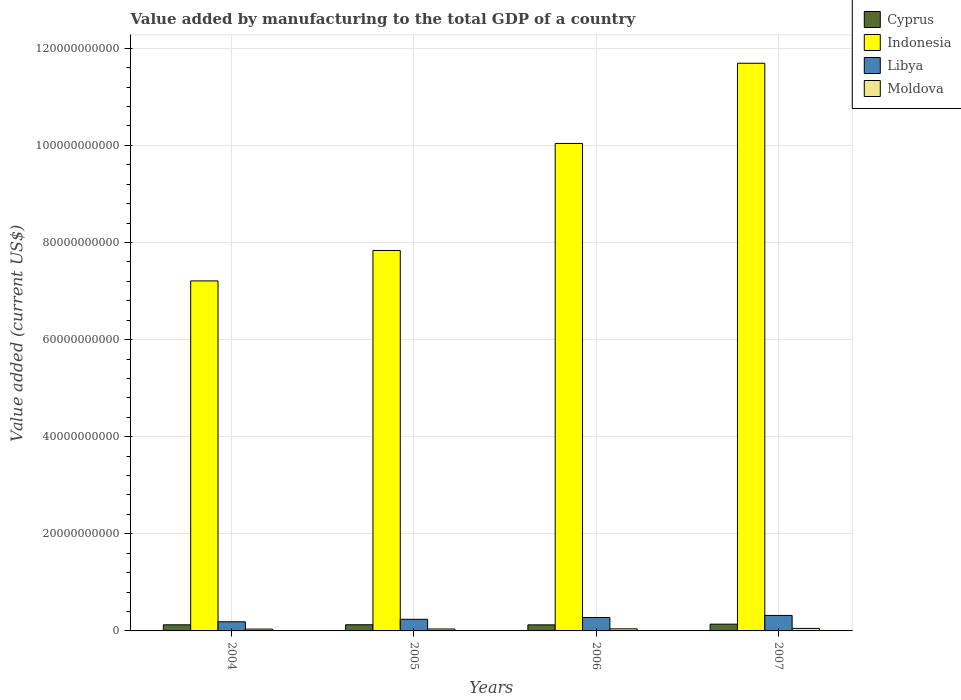How many different coloured bars are there?
Offer a very short reply. 4. How many groups of bars are there?
Offer a very short reply. 4. How many bars are there on the 1st tick from the left?
Give a very brief answer. 4. In how many cases, is the number of bars for a given year not equal to the number of legend labels?
Provide a succinct answer. 0. What is the value added by manufacturing to the total GDP in Libya in 2005?
Ensure brevity in your answer.  2.39e+09. Across all years, what is the maximum value added by manufacturing to the total GDP in Cyprus?
Your answer should be compact. 1.39e+09. Across all years, what is the minimum value added by manufacturing to the total GDP in Indonesia?
Offer a terse response. 7.21e+1. In which year was the value added by manufacturing to the total GDP in Cyprus minimum?
Provide a succinct answer. 2006. What is the total value added by manufacturing to the total GDP in Libya in the graph?
Give a very brief answer. 1.02e+1. What is the difference between the value added by manufacturing to the total GDP in Libya in 2004 and that in 2006?
Your answer should be very brief. -8.85e+08. What is the difference between the value added by manufacturing to the total GDP in Cyprus in 2007 and the value added by manufacturing to the total GDP in Moldova in 2004?
Your response must be concise. 1.02e+09. What is the average value added by manufacturing to the total GDP in Moldova per year?
Give a very brief answer. 4.30e+08. In the year 2006, what is the difference between the value added by manufacturing to the total GDP in Cyprus and value added by manufacturing to the total GDP in Libya?
Give a very brief answer. -1.52e+09. In how many years, is the value added by manufacturing to the total GDP in Cyprus greater than 52000000000 US$?
Provide a succinct answer. 0. What is the ratio of the value added by manufacturing to the total GDP in Libya in 2004 to that in 2006?
Offer a very short reply. 0.68. Is the difference between the value added by manufacturing to the total GDP in Cyprus in 2005 and 2006 greater than the difference between the value added by manufacturing to the total GDP in Libya in 2005 and 2006?
Offer a terse response. Yes. What is the difference between the highest and the second highest value added by manufacturing to the total GDP in Cyprus?
Offer a terse response. 1.26e+08. What is the difference between the highest and the lowest value added by manufacturing to the total GDP in Moldova?
Provide a short and direct response. 1.42e+08. What does the 4th bar from the left in 2004 represents?
Provide a succinct answer. Moldova. What does the 3rd bar from the right in 2006 represents?
Make the answer very short. Indonesia. Are all the bars in the graph horizontal?
Offer a very short reply. No. Are the values on the major ticks of Y-axis written in scientific E-notation?
Provide a short and direct response. No. Does the graph contain grids?
Your answer should be compact. Yes. Where does the legend appear in the graph?
Keep it short and to the point. Top right. How are the legend labels stacked?
Your answer should be very brief. Vertical. What is the title of the graph?
Ensure brevity in your answer.  Value added by manufacturing to the total GDP of a country. Does "Liechtenstein" appear as one of the legend labels in the graph?
Provide a short and direct response. No. What is the label or title of the Y-axis?
Ensure brevity in your answer.  Value added (current US$). What is the Value added (current US$) in Cyprus in 2004?
Provide a short and direct response. 1.26e+09. What is the Value added (current US$) of Indonesia in 2004?
Give a very brief answer. 7.21e+1. What is the Value added (current US$) in Libya in 2004?
Offer a terse response. 1.88e+09. What is the Value added (current US$) in Moldova in 2004?
Make the answer very short. 3.77e+08. What is the Value added (current US$) in Cyprus in 2005?
Offer a terse response. 1.27e+09. What is the Value added (current US$) in Indonesia in 2005?
Your answer should be compact. 7.83e+1. What is the Value added (current US$) in Libya in 2005?
Give a very brief answer. 2.39e+09. What is the Value added (current US$) of Moldova in 2005?
Give a very brief answer. 3.99e+08. What is the Value added (current US$) of Cyprus in 2006?
Offer a very short reply. 1.25e+09. What is the Value added (current US$) of Indonesia in 2006?
Provide a succinct answer. 1.00e+11. What is the Value added (current US$) of Libya in 2006?
Provide a short and direct response. 2.77e+09. What is the Value added (current US$) of Moldova in 2006?
Offer a very short reply. 4.26e+08. What is the Value added (current US$) of Cyprus in 2007?
Make the answer very short. 1.39e+09. What is the Value added (current US$) of Indonesia in 2007?
Offer a very short reply. 1.17e+11. What is the Value added (current US$) of Libya in 2007?
Give a very brief answer. 3.19e+09. What is the Value added (current US$) in Moldova in 2007?
Make the answer very short. 5.19e+08. Across all years, what is the maximum Value added (current US$) in Cyprus?
Your answer should be very brief. 1.39e+09. Across all years, what is the maximum Value added (current US$) of Indonesia?
Make the answer very short. 1.17e+11. Across all years, what is the maximum Value added (current US$) of Libya?
Ensure brevity in your answer.  3.19e+09. Across all years, what is the maximum Value added (current US$) of Moldova?
Ensure brevity in your answer.  5.19e+08. Across all years, what is the minimum Value added (current US$) of Cyprus?
Your answer should be very brief. 1.25e+09. Across all years, what is the minimum Value added (current US$) in Indonesia?
Your answer should be compact. 7.21e+1. Across all years, what is the minimum Value added (current US$) of Libya?
Provide a short and direct response. 1.88e+09. Across all years, what is the minimum Value added (current US$) in Moldova?
Keep it short and to the point. 3.77e+08. What is the total Value added (current US$) of Cyprus in the graph?
Offer a terse response. 5.17e+09. What is the total Value added (current US$) of Indonesia in the graph?
Offer a terse response. 3.68e+11. What is the total Value added (current US$) in Libya in the graph?
Ensure brevity in your answer.  1.02e+1. What is the total Value added (current US$) of Moldova in the graph?
Your answer should be compact. 1.72e+09. What is the difference between the Value added (current US$) of Cyprus in 2004 and that in 2005?
Make the answer very short. -7.21e+06. What is the difference between the Value added (current US$) in Indonesia in 2004 and that in 2005?
Make the answer very short. -6.27e+09. What is the difference between the Value added (current US$) in Libya in 2004 and that in 2005?
Offer a very short reply. -5.10e+08. What is the difference between the Value added (current US$) in Moldova in 2004 and that in 2005?
Provide a short and direct response. -2.13e+07. What is the difference between the Value added (current US$) in Cyprus in 2004 and that in 2006?
Provide a succinct answer. 1.54e+07. What is the difference between the Value added (current US$) of Indonesia in 2004 and that in 2006?
Your response must be concise. -2.83e+1. What is the difference between the Value added (current US$) in Libya in 2004 and that in 2006?
Make the answer very short. -8.85e+08. What is the difference between the Value added (current US$) in Moldova in 2004 and that in 2006?
Make the answer very short. -4.92e+07. What is the difference between the Value added (current US$) in Cyprus in 2004 and that in 2007?
Your response must be concise. -1.34e+08. What is the difference between the Value added (current US$) of Indonesia in 2004 and that in 2007?
Ensure brevity in your answer.  -4.48e+1. What is the difference between the Value added (current US$) in Libya in 2004 and that in 2007?
Make the answer very short. -1.31e+09. What is the difference between the Value added (current US$) in Moldova in 2004 and that in 2007?
Your answer should be very brief. -1.42e+08. What is the difference between the Value added (current US$) in Cyprus in 2005 and that in 2006?
Make the answer very short. 2.26e+07. What is the difference between the Value added (current US$) in Indonesia in 2005 and that in 2006?
Your answer should be very brief. -2.20e+1. What is the difference between the Value added (current US$) in Libya in 2005 and that in 2006?
Make the answer very short. -3.75e+08. What is the difference between the Value added (current US$) of Moldova in 2005 and that in 2006?
Offer a terse response. -2.78e+07. What is the difference between the Value added (current US$) in Cyprus in 2005 and that in 2007?
Your response must be concise. -1.26e+08. What is the difference between the Value added (current US$) of Indonesia in 2005 and that in 2007?
Make the answer very short. -3.86e+1. What is the difference between the Value added (current US$) in Libya in 2005 and that in 2007?
Ensure brevity in your answer.  -7.98e+08. What is the difference between the Value added (current US$) of Moldova in 2005 and that in 2007?
Offer a very short reply. -1.20e+08. What is the difference between the Value added (current US$) of Cyprus in 2006 and that in 2007?
Keep it short and to the point. -1.49e+08. What is the difference between the Value added (current US$) of Indonesia in 2006 and that in 2007?
Ensure brevity in your answer.  -1.65e+1. What is the difference between the Value added (current US$) in Libya in 2006 and that in 2007?
Provide a short and direct response. -4.23e+08. What is the difference between the Value added (current US$) of Moldova in 2006 and that in 2007?
Your answer should be very brief. -9.26e+07. What is the difference between the Value added (current US$) of Cyprus in 2004 and the Value added (current US$) of Indonesia in 2005?
Provide a succinct answer. -7.71e+1. What is the difference between the Value added (current US$) in Cyprus in 2004 and the Value added (current US$) in Libya in 2005?
Provide a succinct answer. -1.13e+09. What is the difference between the Value added (current US$) of Cyprus in 2004 and the Value added (current US$) of Moldova in 2005?
Provide a succinct answer. 8.62e+08. What is the difference between the Value added (current US$) of Indonesia in 2004 and the Value added (current US$) of Libya in 2005?
Make the answer very short. 6.97e+1. What is the difference between the Value added (current US$) in Indonesia in 2004 and the Value added (current US$) in Moldova in 2005?
Your answer should be very brief. 7.17e+1. What is the difference between the Value added (current US$) in Libya in 2004 and the Value added (current US$) in Moldova in 2005?
Provide a succinct answer. 1.49e+09. What is the difference between the Value added (current US$) in Cyprus in 2004 and the Value added (current US$) in Indonesia in 2006?
Offer a very short reply. -9.91e+1. What is the difference between the Value added (current US$) of Cyprus in 2004 and the Value added (current US$) of Libya in 2006?
Make the answer very short. -1.51e+09. What is the difference between the Value added (current US$) in Cyprus in 2004 and the Value added (current US$) in Moldova in 2006?
Offer a very short reply. 8.35e+08. What is the difference between the Value added (current US$) of Indonesia in 2004 and the Value added (current US$) of Libya in 2006?
Make the answer very short. 6.93e+1. What is the difference between the Value added (current US$) in Indonesia in 2004 and the Value added (current US$) in Moldova in 2006?
Provide a short and direct response. 7.17e+1. What is the difference between the Value added (current US$) in Libya in 2004 and the Value added (current US$) in Moldova in 2006?
Make the answer very short. 1.46e+09. What is the difference between the Value added (current US$) of Cyprus in 2004 and the Value added (current US$) of Indonesia in 2007?
Make the answer very short. -1.16e+11. What is the difference between the Value added (current US$) in Cyprus in 2004 and the Value added (current US$) in Libya in 2007?
Your answer should be compact. -1.93e+09. What is the difference between the Value added (current US$) in Cyprus in 2004 and the Value added (current US$) in Moldova in 2007?
Your answer should be very brief. 7.42e+08. What is the difference between the Value added (current US$) in Indonesia in 2004 and the Value added (current US$) in Libya in 2007?
Offer a very short reply. 6.89e+1. What is the difference between the Value added (current US$) of Indonesia in 2004 and the Value added (current US$) of Moldova in 2007?
Give a very brief answer. 7.16e+1. What is the difference between the Value added (current US$) in Libya in 2004 and the Value added (current US$) in Moldova in 2007?
Offer a terse response. 1.36e+09. What is the difference between the Value added (current US$) of Cyprus in 2005 and the Value added (current US$) of Indonesia in 2006?
Your response must be concise. -9.91e+1. What is the difference between the Value added (current US$) in Cyprus in 2005 and the Value added (current US$) in Libya in 2006?
Provide a short and direct response. -1.50e+09. What is the difference between the Value added (current US$) in Cyprus in 2005 and the Value added (current US$) in Moldova in 2006?
Make the answer very short. 8.42e+08. What is the difference between the Value added (current US$) of Indonesia in 2005 and the Value added (current US$) of Libya in 2006?
Your answer should be very brief. 7.56e+1. What is the difference between the Value added (current US$) of Indonesia in 2005 and the Value added (current US$) of Moldova in 2006?
Keep it short and to the point. 7.79e+1. What is the difference between the Value added (current US$) in Libya in 2005 and the Value added (current US$) in Moldova in 2006?
Keep it short and to the point. 1.97e+09. What is the difference between the Value added (current US$) of Cyprus in 2005 and the Value added (current US$) of Indonesia in 2007?
Your answer should be compact. -1.16e+11. What is the difference between the Value added (current US$) in Cyprus in 2005 and the Value added (current US$) in Libya in 2007?
Give a very brief answer. -1.92e+09. What is the difference between the Value added (current US$) of Cyprus in 2005 and the Value added (current US$) of Moldova in 2007?
Your answer should be compact. 7.49e+08. What is the difference between the Value added (current US$) of Indonesia in 2005 and the Value added (current US$) of Libya in 2007?
Provide a short and direct response. 7.52e+1. What is the difference between the Value added (current US$) of Indonesia in 2005 and the Value added (current US$) of Moldova in 2007?
Provide a succinct answer. 7.78e+1. What is the difference between the Value added (current US$) in Libya in 2005 and the Value added (current US$) in Moldova in 2007?
Offer a very short reply. 1.87e+09. What is the difference between the Value added (current US$) of Cyprus in 2006 and the Value added (current US$) of Indonesia in 2007?
Keep it short and to the point. -1.16e+11. What is the difference between the Value added (current US$) of Cyprus in 2006 and the Value added (current US$) of Libya in 2007?
Make the answer very short. -1.95e+09. What is the difference between the Value added (current US$) in Cyprus in 2006 and the Value added (current US$) in Moldova in 2007?
Offer a very short reply. 7.27e+08. What is the difference between the Value added (current US$) in Indonesia in 2006 and the Value added (current US$) in Libya in 2007?
Ensure brevity in your answer.  9.72e+1. What is the difference between the Value added (current US$) in Indonesia in 2006 and the Value added (current US$) in Moldova in 2007?
Keep it short and to the point. 9.99e+1. What is the difference between the Value added (current US$) in Libya in 2006 and the Value added (current US$) in Moldova in 2007?
Make the answer very short. 2.25e+09. What is the average Value added (current US$) of Cyprus per year?
Your response must be concise. 1.29e+09. What is the average Value added (current US$) in Indonesia per year?
Keep it short and to the point. 9.19e+1. What is the average Value added (current US$) in Libya per year?
Your answer should be compact. 2.56e+09. What is the average Value added (current US$) of Moldova per year?
Ensure brevity in your answer.  4.30e+08. In the year 2004, what is the difference between the Value added (current US$) of Cyprus and Value added (current US$) of Indonesia?
Give a very brief answer. -7.08e+1. In the year 2004, what is the difference between the Value added (current US$) in Cyprus and Value added (current US$) in Libya?
Offer a very short reply. -6.23e+08. In the year 2004, what is the difference between the Value added (current US$) in Cyprus and Value added (current US$) in Moldova?
Give a very brief answer. 8.84e+08. In the year 2004, what is the difference between the Value added (current US$) of Indonesia and Value added (current US$) of Libya?
Your answer should be compact. 7.02e+1. In the year 2004, what is the difference between the Value added (current US$) in Indonesia and Value added (current US$) in Moldova?
Keep it short and to the point. 7.17e+1. In the year 2004, what is the difference between the Value added (current US$) of Libya and Value added (current US$) of Moldova?
Your answer should be compact. 1.51e+09. In the year 2005, what is the difference between the Value added (current US$) of Cyprus and Value added (current US$) of Indonesia?
Provide a short and direct response. -7.71e+1. In the year 2005, what is the difference between the Value added (current US$) of Cyprus and Value added (current US$) of Libya?
Your response must be concise. -1.13e+09. In the year 2005, what is the difference between the Value added (current US$) in Cyprus and Value added (current US$) in Moldova?
Give a very brief answer. 8.70e+08. In the year 2005, what is the difference between the Value added (current US$) in Indonesia and Value added (current US$) in Libya?
Your answer should be compact. 7.60e+1. In the year 2005, what is the difference between the Value added (current US$) of Indonesia and Value added (current US$) of Moldova?
Provide a succinct answer. 7.80e+1. In the year 2005, what is the difference between the Value added (current US$) of Libya and Value added (current US$) of Moldova?
Provide a short and direct response. 1.99e+09. In the year 2006, what is the difference between the Value added (current US$) in Cyprus and Value added (current US$) in Indonesia?
Offer a very short reply. -9.91e+1. In the year 2006, what is the difference between the Value added (current US$) in Cyprus and Value added (current US$) in Libya?
Ensure brevity in your answer.  -1.52e+09. In the year 2006, what is the difference between the Value added (current US$) of Cyprus and Value added (current US$) of Moldova?
Keep it short and to the point. 8.19e+08. In the year 2006, what is the difference between the Value added (current US$) in Indonesia and Value added (current US$) in Libya?
Give a very brief answer. 9.76e+1. In the year 2006, what is the difference between the Value added (current US$) of Indonesia and Value added (current US$) of Moldova?
Keep it short and to the point. 1.00e+11. In the year 2006, what is the difference between the Value added (current US$) of Libya and Value added (current US$) of Moldova?
Your answer should be compact. 2.34e+09. In the year 2007, what is the difference between the Value added (current US$) in Cyprus and Value added (current US$) in Indonesia?
Your response must be concise. -1.16e+11. In the year 2007, what is the difference between the Value added (current US$) in Cyprus and Value added (current US$) in Libya?
Keep it short and to the point. -1.80e+09. In the year 2007, what is the difference between the Value added (current US$) in Cyprus and Value added (current US$) in Moldova?
Your answer should be compact. 8.76e+08. In the year 2007, what is the difference between the Value added (current US$) in Indonesia and Value added (current US$) in Libya?
Your answer should be compact. 1.14e+11. In the year 2007, what is the difference between the Value added (current US$) of Indonesia and Value added (current US$) of Moldova?
Make the answer very short. 1.16e+11. In the year 2007, what is the difference between the Value added (current US$) of Libya and Value added (current US$) of Moldova?
Provide a short and direct response. 2.67e+09. What is the ratio of the Value added (current US$) in Cyprus in 2004 to that in 2005?
Ensure brevity in your answer.  0.99. What is the ratio of the Value added (current US$) of Libya in 2004 to that in 2005?
Your answer should be very brief. 0.79. What is the ratio of the Value added (current US$) in Moldova in 2004 to that in 2005?
Your response must be concise. 0.95. What is the ratio of the Value added (current US$) in Cyprus in 2004 to that in 2006?
Ensure brevity in your answer.  1.01. What is the ratio of the Value added (current US$) in Indonesia in 2004 to that in 2006?
Offer a very short reply. 0.72. What is the ratio of the Value added (current US$) in Libya in 2004 to that in 2006?
Keep it short and to the point. 0.68. What is the ratio of the Value added (current US$) in Moldova in 2004 to that in 2006?
Your response must be concise. 0.88. What is the ratio of the Value added (current US$) in Cyprus in 2004 to that in 2007?
Provide a succinct answer. 0.9. What is the ratio of the Value added (current US$) of Indonesia in 2004 to that in 2007?
Ensure brevity in your answer.  0.62. What is the ratio of the Value added (current US$) of Libya in 2004 to that in 2007?
Give a very brief answer. 0.59. What is the ratio of the Value added (current US$) of Moldova in 2004 to that in 2007?
Offer a terse response. 0.73. What is the ratio of the Value added (current US$) of Cyprus in 2005 to that in 2006?
Keep it short and to the point. 1.02. What is the ratio of the Value added (current US$) of Indonesia in 2005 to that in 2006?
Ensure brevity in your answer.  0.78. What is the ratio of the Value added (current US$) in Libya in 2005 to that in 2006?
Provide a short and direct response. 0.86. What is the ratio of the Value added (current US$) in Moldova in 2005 to that in 2006?
Provide a succinct answer. 0.93. What is the ratio of the Value added (current US$) in Cyprus in 2005 to that in 2007?
Offer a terse response. 0.91. What is the ratio of the Value added (current US$) of Indonesia in 2005 to that in 2007?
Provide a succinct answer. 0.67. What is the ratio of the Value added (current US$) of Libya in 2005 to that in 2007?
Give a very brief answer. 0.75. What is the ratio of the Value added (current US$) in Moldova in 2005 to that in 2007?
Make the answer very short. 0.77. What is the ratio of the Value added (current US$) in Cyprus in 2006 to that in 2007?
Ensure brevity in your answer.  0.89. What is the ratio of the Value added (current US$) of Indonesia in 2006 to that in 2007?
Make the answer very short. 0.86. What is the ratio of the Value added (current US$) of Libya in 2006 to that in 2007?
Offer a very short reply. 0.87. What is the ratio of the Value added (current US$) in Moldova in 2006 to that in 2007?
Offer a very short reply. 0.82. What is the difference between the highest and the second highest Value added (current US$) in Cyprus?
Your response must be concise. 1.26e+08. What is the difference between the highest and the second highest Value added (current US$) in Indonesia?
Provide a succinct answer. 1.65e+1. What is the difference between the highest and the second highest Value added (current US$) of Libya?
Your answer should be very brief. 4.23e+08. What is the difference between the highest and the second highest Value added (current US$) of Moldova?
Provide a short and direct response. 9.26e+07. What is the difference between the highest and the lowest Value added (current US$) in Cyprus?
Offer a terse response. 1.49e+08. What is the difference between the highest and the lowest Value added (current US$) of Indonesia?
Make the answer very short. 4.48e+1. What is the difference between the highest and the lowest Value added (current US$) of Libya?
Give a very brief answer. 1.31e+09. What is the difference between the highest and the lowest Value added (current US$) of Moldova?
Your answer should be very brief. 1.42e+08. 